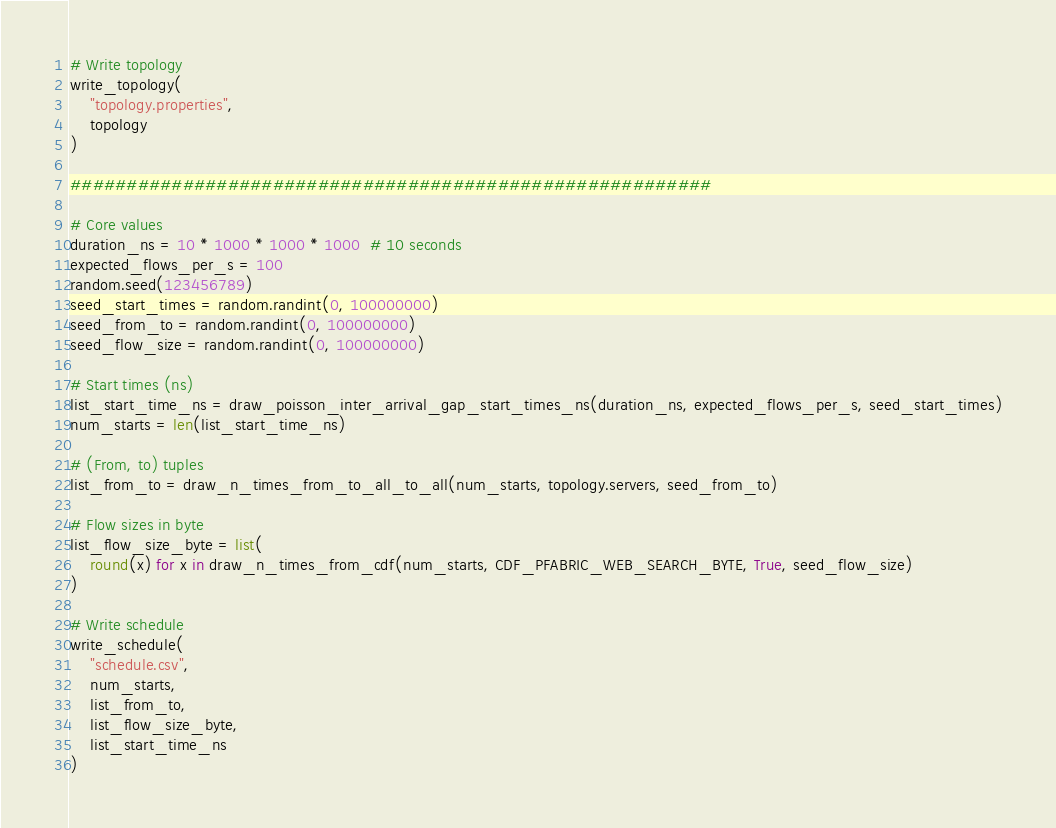Convert code to text. <code><loc_0><loc_0><loc_500><loc_500><_Python_># Write topology
write_topology(
    "topology.properties",
    topology
)

#########################################################

# Core values
duration_ns = 10 * 1000 * 1000 * 1000  # 10 seconds
expected_flows_per_s = 100
random.seed(123456789)
seed_start_times = random.randint(0, 100000000)
seed_from_to = random.randint(0, 100000000)
seed_flow_size = random.randint(0, 100000000)

# Start times (ns)
list_start_time_ns = draw_poisson_inter_arrival_gap_start_times_ns(duration_ns, expected_flows_per_s, seed_start_times)
num_starts = len(list_start_time_ns)

# (From, to) tuples
list_from_to = draw_n_times_from_to_all_to_all(num_starts, topology.servers, seed_from_to)

# Flow sizes in byte
list_flow_size_byte = list(
    round(x) for x in draw_n_times_from_cdf(num_starts, CDF_PFABRIC_WEB_SEARCH_BYTE, True, seed_flow_size)
)

# Write schedule
write_schedule(
    "schedule.csv",
    num_starts,
    list_from_to,
    list_flow_size_byte,
    list_start_time_ns
)
</code> 